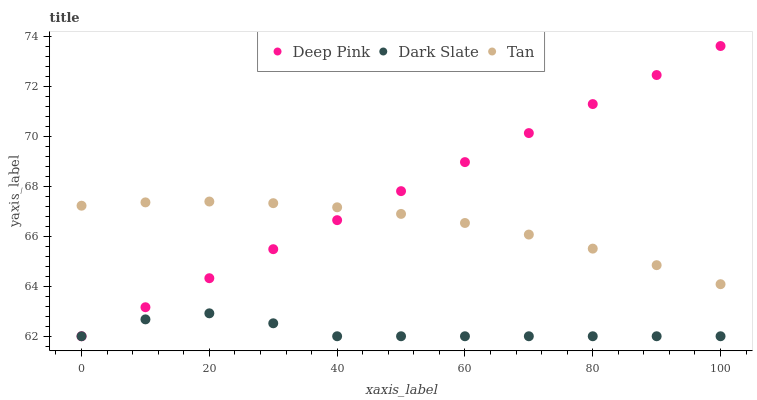Does Dark Slate have the minimum area under the curve?
Answer yes or no. Yes. Does Deep Pink have the maximum area under the curve?
Answer yes or no. Yes. Does Tan have the minimum area under the curve?
Answer yes or no. No. Does Tan have the maximum area under the curve?
Answer yes or no. No. Is Deep Pink the smoothest?
Answer yes or no. Yes. Is Dark Slate the roughest?
Answer yes or no. Yes. Is Tan the smoothest?
Answer yes or no. No. Is Tan the roughest?
Answer yes or no. No. Does Dark Slate have the lowest value?
Answer yes or no. Yes. Does Tan have the lowest value?
Answer yes or no. No. Does Deep Pink have the highest value?
Answer yes or no. Yes. Does Tan have the highest value?
Answer yes or no. No. Is Dark Slate less than Tan?
Answer yes or no. Yes. Is Tan greater than Dark Slate?
Answer yes or no. Yes. Does Deep Pink intersect Dark Slate?
Answer yes or no. Yes. Is Deep Pink less than Dark Slate?
Answer yes or no. No. Is Deep Pink greater than Dark Slate?
Answer yes or no. No. Does Dark Slate intersect Tan?
Answer yes or no. No. 